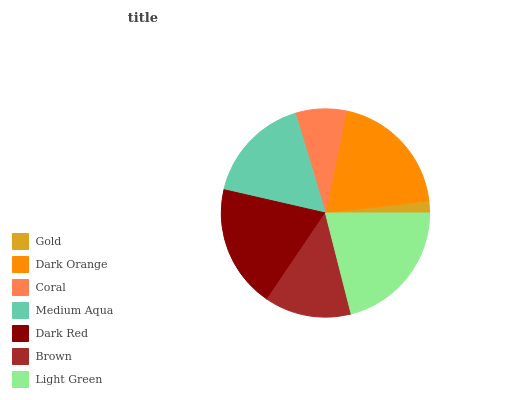Is Gold the minimum?
Answer yes or no. Yes. Is Light Green the maximum?
Answer yes or no. Yes. Is Dark Orange the minimum?
Answer yes or no. No. Is Dark Orange the maximum?
Answer yes or no. No. Is Dark Orange greater than Gold?
Answer yes or no. Yes. Is Gold less than Dark Orange?
Answer yes or no. Yes. Is Gold greater than Dark Orange?
Answer yes or no. No. Is Dark Orange less than Gold?
Answer yes or no. No. Is Medium Aqua the high median?
Answer yes or no. Yes. Is Medium Aqua the low median?
Answer yes or no. Yes. Is Light Green the high median?
Answer yes or no. No. Is Dark Red the low median?
Answer yes or no. No. 